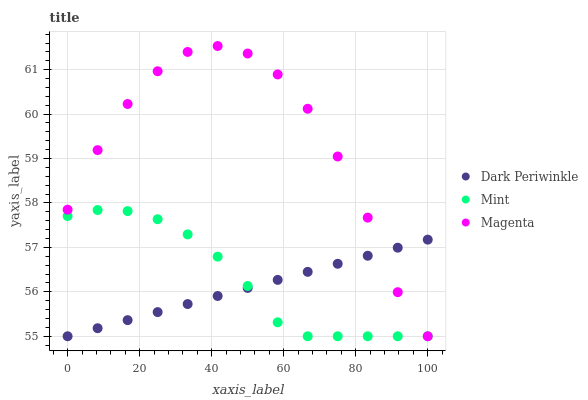Does Dark Periwinkle have the minimum area under the curve?
Answer yes or no. Yes. Does Magenta have the maximum area under the curve?
Answer yes or no. Yes. Does Mint have the minimum area under the curve?
Answer yes or no. No. Does Mint have the maximum area under the curve?
Answer yes or no. No. Is Dark Periwinkle the smoothest?
Answer yes or no. Yes. Is Magenta the roughest?
Answer yes or no. Yes. Is Mint the smoothest?
Answer yes or no. No. Is Mint the roughest?
Answer yes or no. No. Does Magenta have the lowest value?
Answer yes or no. Yes. Does Magenta have the highest value?
Answer yes or no. Yes. Does Mint have the highest value?
Answer yes or no. No. Does Dark Periwinkle intersect Magenta?
Answer yes or no. Yes. Is Dark Periwinkle less than Magenta?
Answer yes or no. No. Is Dark Periwinkle greater than Magenta?
Answer yes or no. No. 